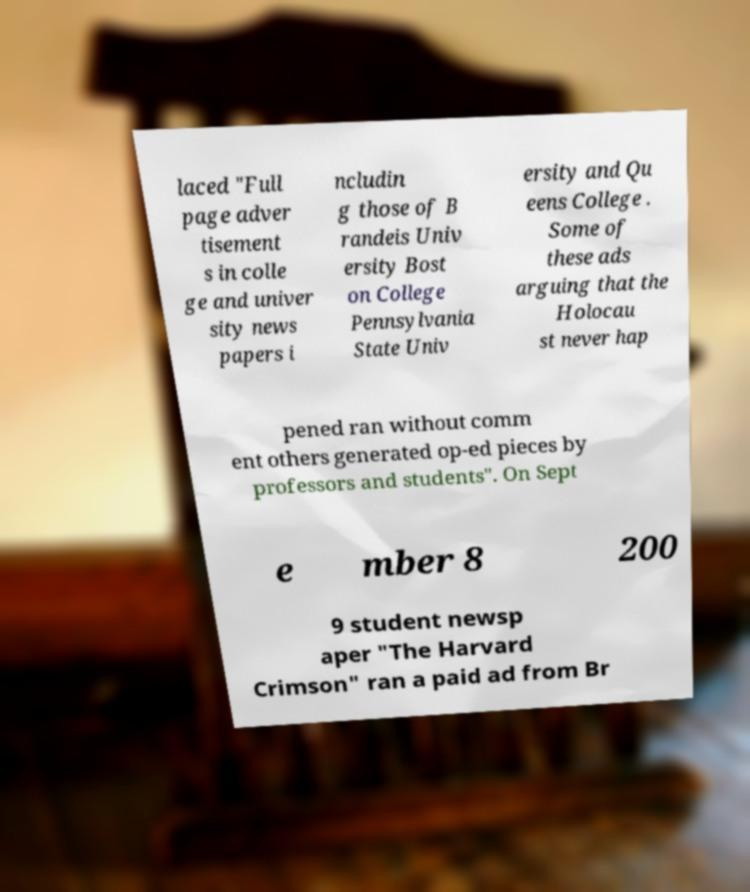What messages or text are displayed in this image? I need them in a readable, typed format. laced "Full page adver tisement s in colle ge and univer sity news papers i ncludin g those of B randeis Univ ersity Bost on College Pennsylvania State Univ ersity and Qu eens College . Some of these ads arguing that the Holocau st never hap pened ran without comm ent others generated op-ed pieces by professors and students". On Sept e mber 8 200 9 student newsp aper "The Harvard Crimson" ran a paid ad from Br 